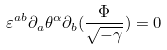<formula> <loc_0><loc_0><loc_500><loc_500>\varepsilon ^ { a b } \partial _ { a } \theta ^ { \alpha } \partial _ { b } ( \frac { \Phi } { \sqrt { - \gamma } } ) = 0</formula> 